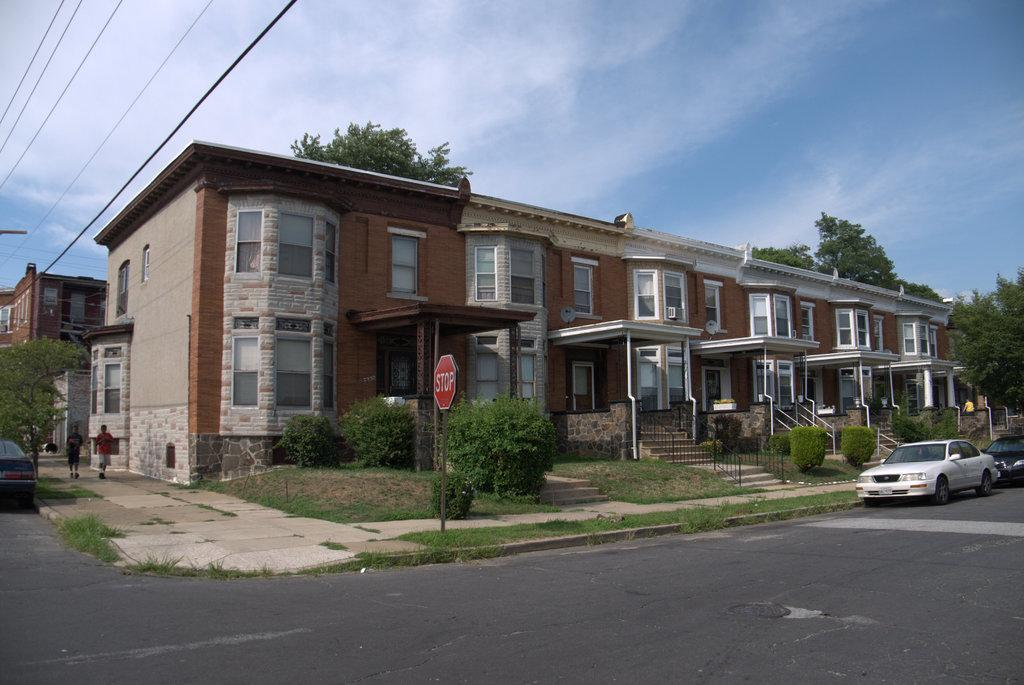What type of structures can be seen in the image? There are buildings in the image. Are there any architectural features related to accessibility? Yes, there are staircases and railings present in the image. What can be seen on the buildings or walls in the image? Sign boards are visible in the image. What mode of transportation is present on the road in the image? Motor vehicles are on the road in the image. What are the people in the image doing? There are persons walking on the floor in the image. What other elements can be seen in the image? Electric cables and trees are visible in the image. What is visible in the background of the image? The sky is visible in the image, and clouds are present in the sky. What type of cabbage is being used as a shade for the motor vehicles in the image? There is no cabbage present in the image, and motor vehicles are not being shaded by any vegetable. Can you identify the actor who is walking on the floor in the image? There is no actor present in the image, and the people walking on the floor are not identified as actors. 